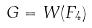<formula> <loc_0><loc_0><loc_500><loc_500>G = W ( F _ { 4 } )</formula> 